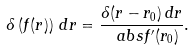Convert formula to latex. <formula><loc_0><loc_0><loc_500><loc_500>\delta \left ( f ( r ) \right ) \, d r = \frac { \delta ( r - r _ { 0 } ) \, d r } { \ a b s { f ^ { \prime } ( r _ { 0 } ) } } .</formula> 